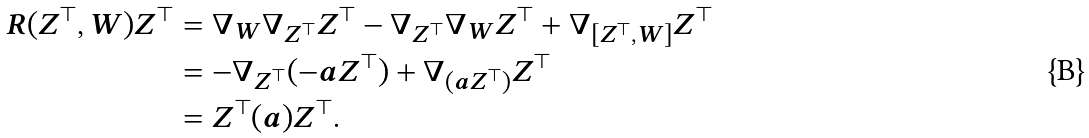<formula> <loc_0><loc_0><loc_500><loc_500>R ( Z ^ { \top } , W ) Z ^ { \top } & = \nabla _ { W } \nabla _ { Z ^ { \top } } Z ^ { \top } - \nabla _ { Z ^ { \top } } \nabla _ { W } Z ^ { \top } + \nabla _ { [ Z ^ { \top } , W ] } Z ^ { \top } \\ & = - \nabla _ { Z ^ { \top } } ( - a Z ^ { \top } ) + \nabla _ { ( a Z ^ { \top } ) } Z ^ { \top } \\ & = Z ^ { \top } ( a ) Z ^ { \top } .</formula> 